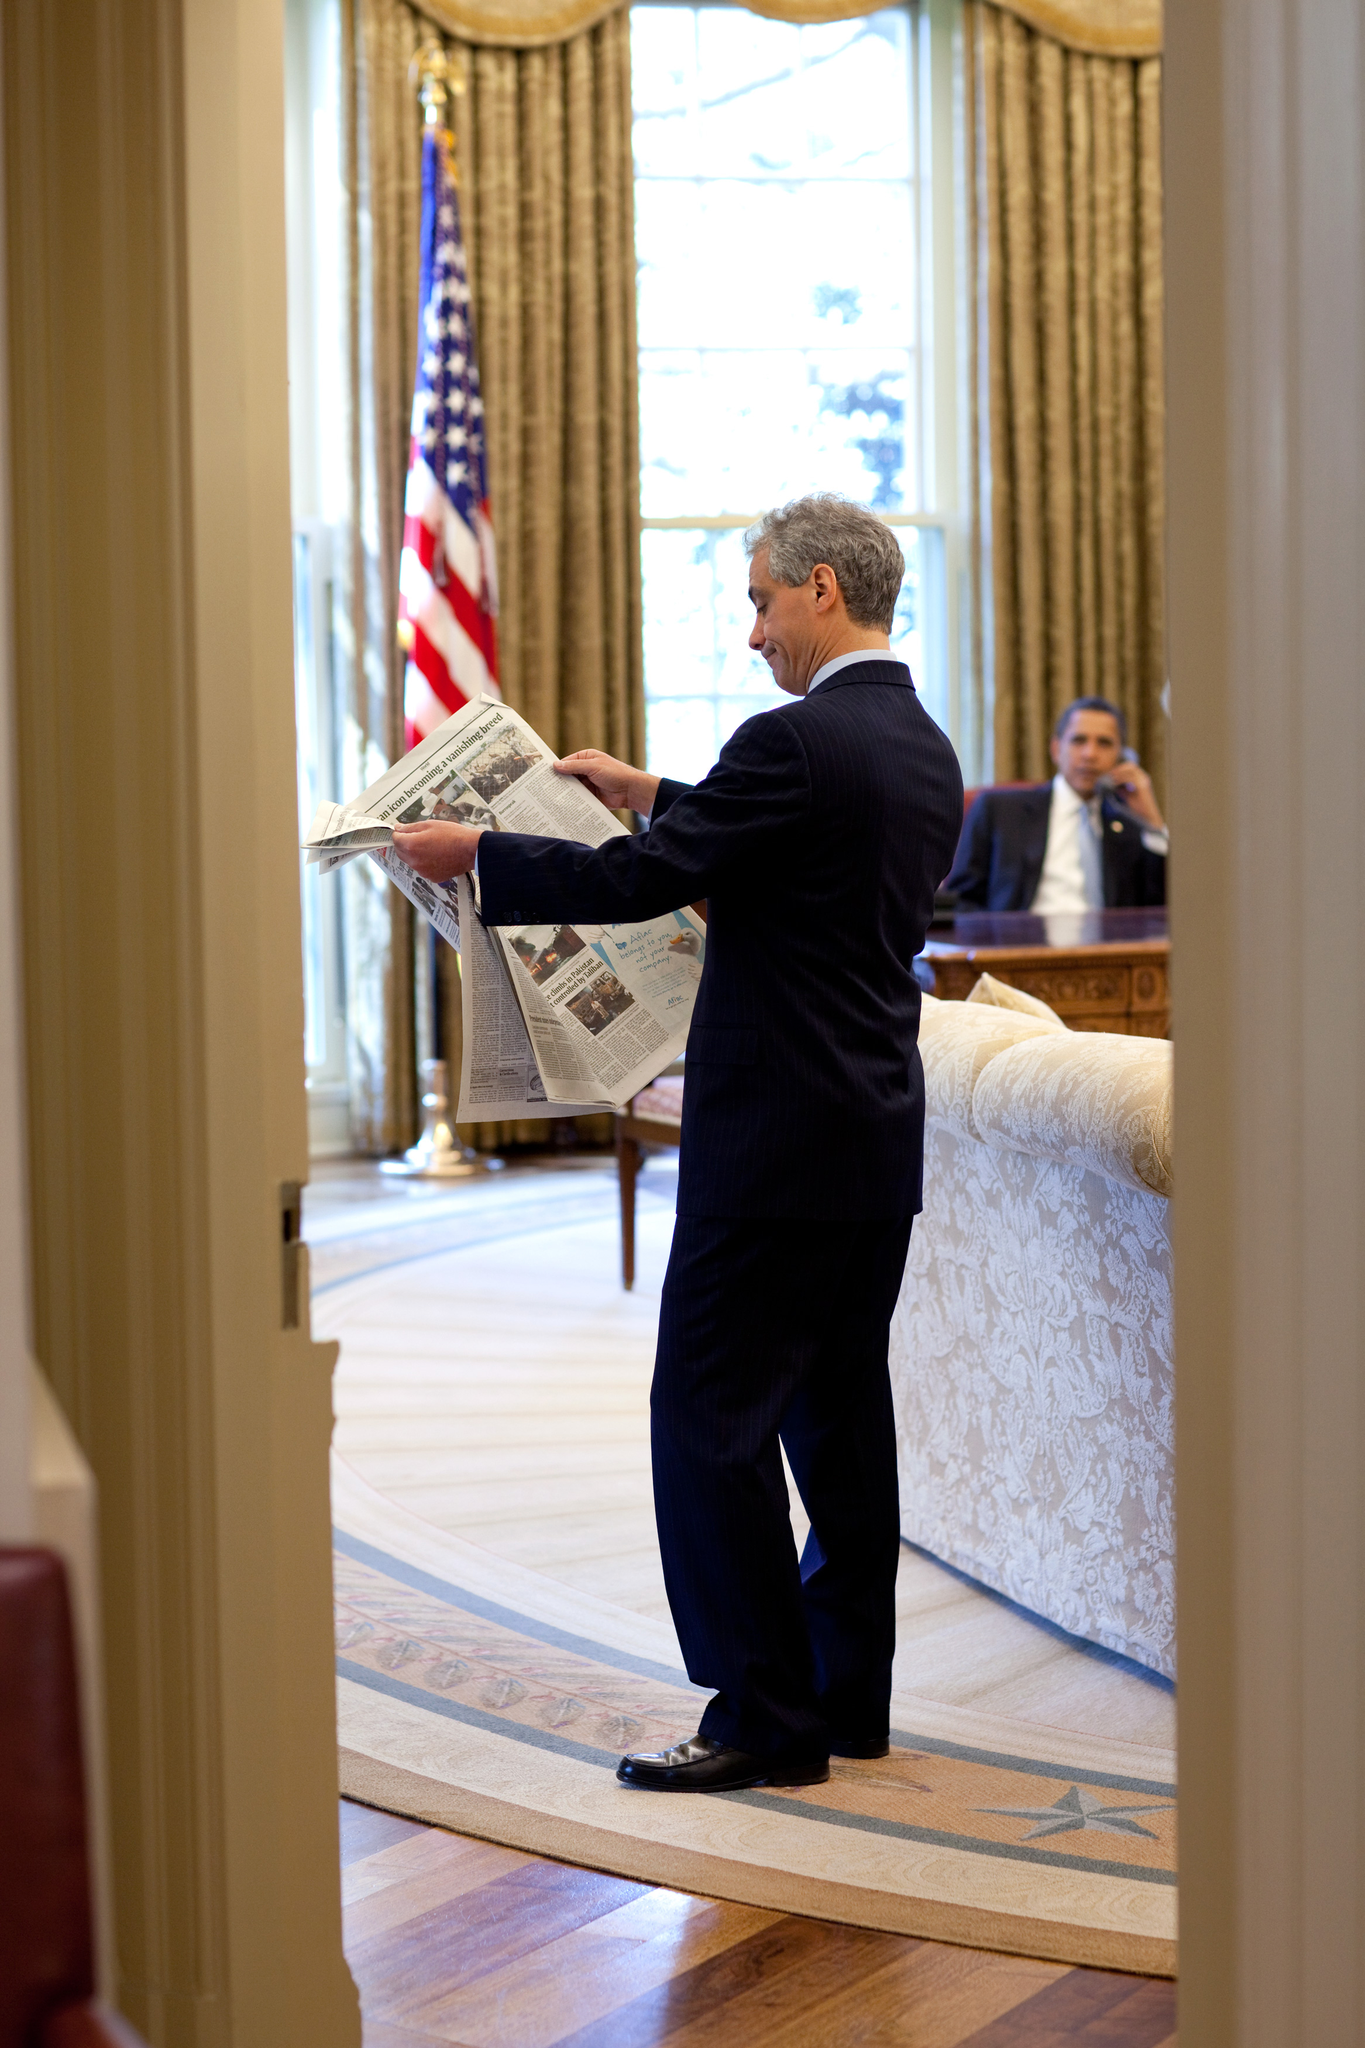Based on the image, what time of year does this scene likely depict, considering the presence of snow-capped mountains and the overall appearance of the landscape? The image likely portrays late spring or early summer. This is deduced from the lingering snow atop the mountain peaks, indicating the remnants of winter, partnered with the vibrant green foliage thriving around the serene lake, a sign of spring's life-giving warmth. The luminous quality of light and the clear sky also hint at longer days typical of early summer, offering a serene and refreshing ambiance ideal for outdoor ventures. 